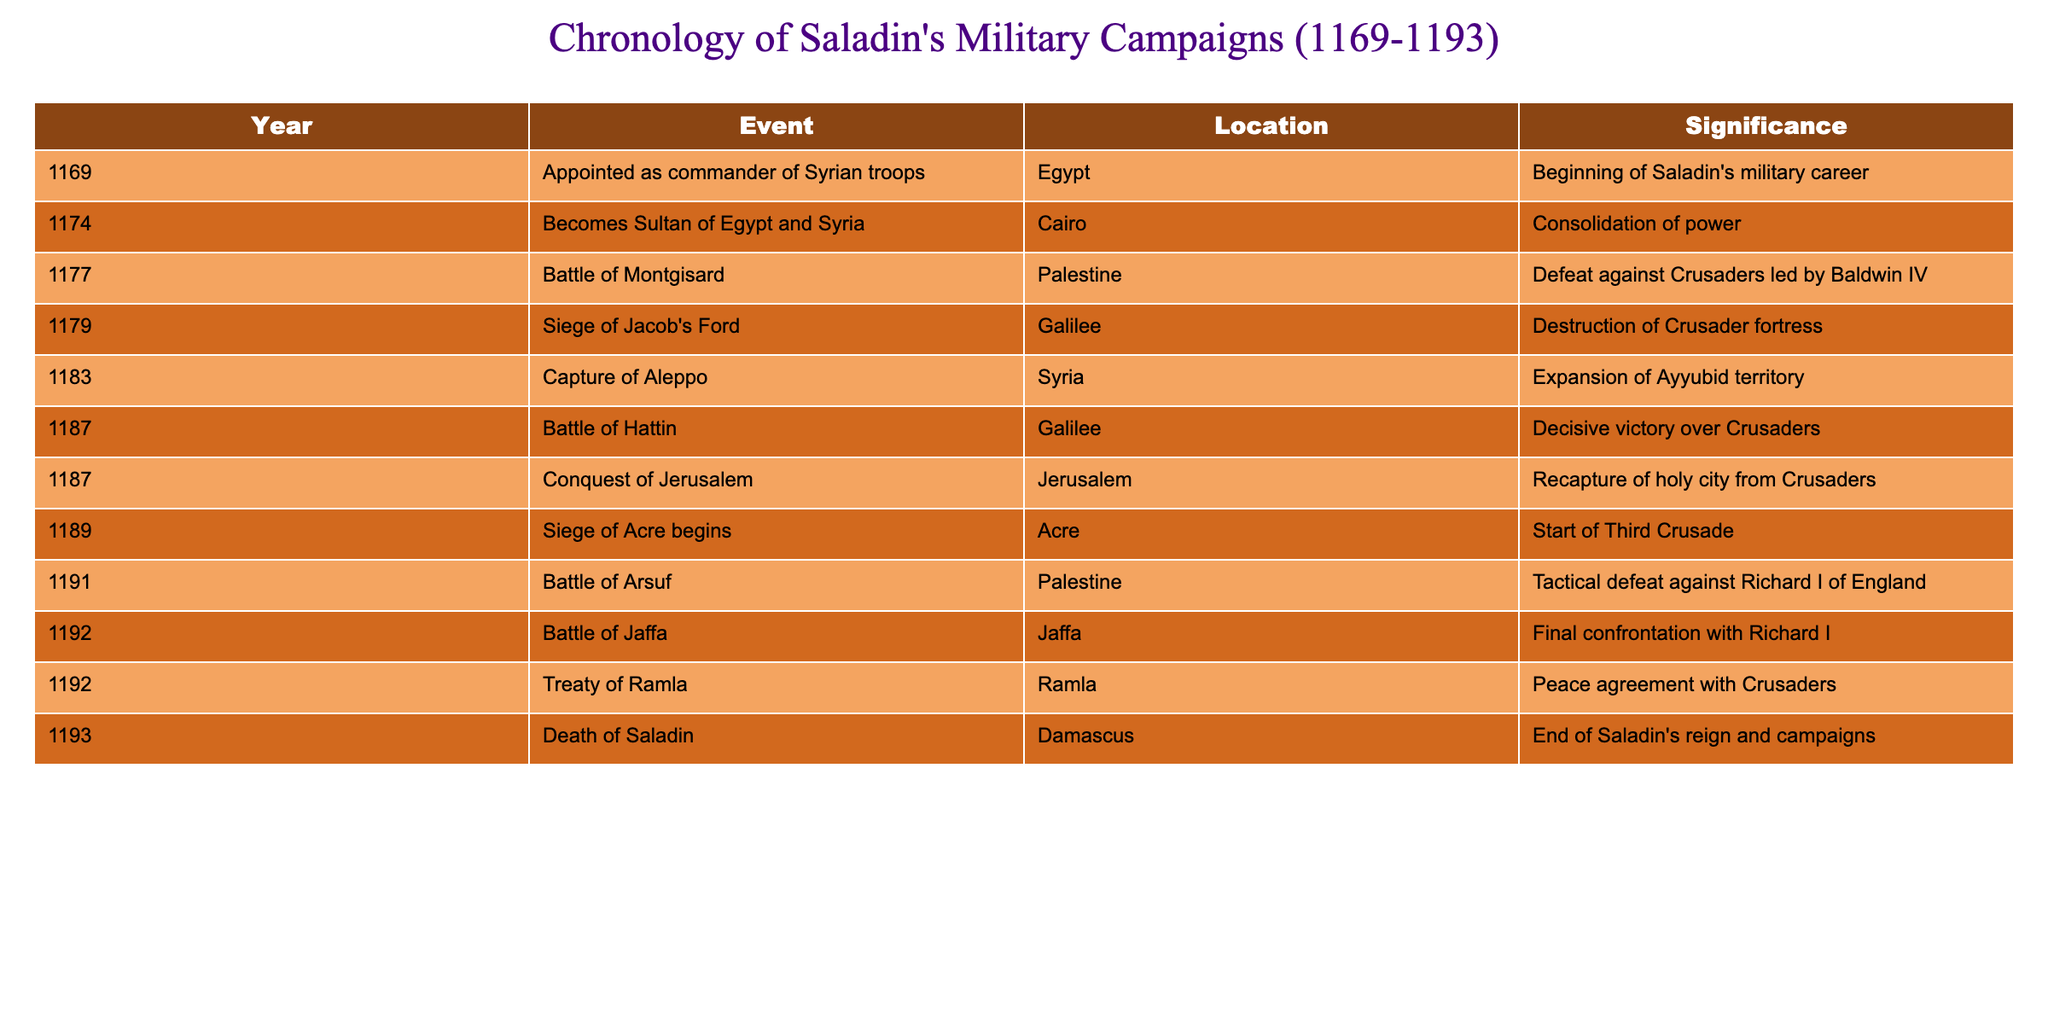What year did Saladin become Sultan of Egypt and Syria? The table indicates that Saladin became the Sultan of Egypt and Syria in the year 1174. This event is explicitly listed in the data for that year.
Answer: 1174 What event occurred in 1187? The table shows two significant events under the year 1187: the Battle of Hattin and the Conquest of Jerusalem. This indicates that both events took place that year.
Answer: Battle of Hattin and Conquest of Jerusalem How many military campaigns are listed for the year 1192? The table lists three events for the year 1192: Battle of Jaffa, Treaty of Ramla, and the final confrontation with Richard I. Counting these events shows there are three listed.
Answer: 3 Was the Siege of Acre part of Saladin's campaigns? Yes, the table confirms that the Siege of Acre began in 1189, marking it as part of Saladin's military endeavors during this period.
Answer: Yes What was the significance of the Battle of Hattin? The Battle of Hattin is noted in the table as a decisive victory over the Crusaders in 1187. This highlights its importance in Saladin's military campaigns.
Answer: Decisive victory over Crusaders Which events were related to Richard I of England? The table shows two events involving Richard I: the Battle of Arsuf in 1191, where Saladin faced a tactical defeat, and the Treaty of Ramla in 1192, which was a peace agreement following confrontations with him.
Answer: Battle of Arsuf and Treaty of Ramla What events occurred after Saladin captured Aleppo? After the capture of Aleppo in 1183, the following events listed in the table include the Battle of Hattin and the Conquest of Jerusalem in 1187. This indicates a continuation of Saladin's military successes after securing Aleppo.
Answer: Battle of Hattin and Conquest of Jerusalem In what location did Saladin die? The table clearly states that Saladin died in Damascus in 1193, marking the end of his reign and military campaigns.
Answer: Damascus What is the difference in years between the Siege of Acre and Saladin's death? The Siege of Acre began in 1189 and Saladin died in 1193, which means the difference in years is 1193 - 1189 = 4 years.
Answer: 4 years 